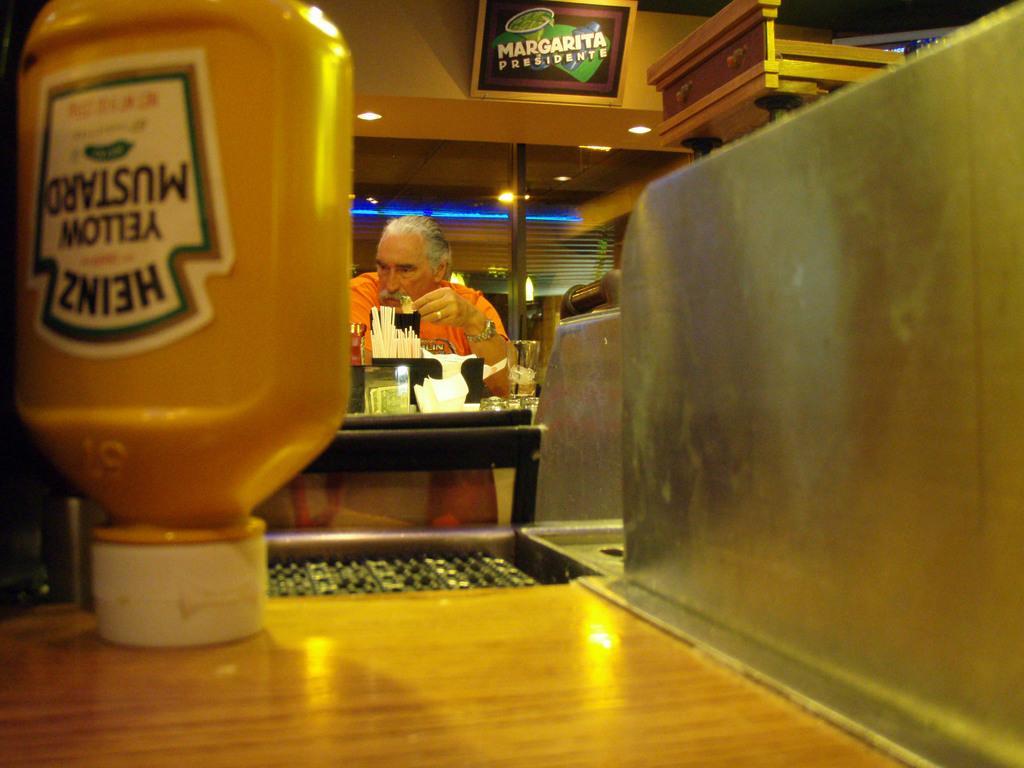How would you summarize this image in a sentence or two? In this image there is a table on that their is a bottle, in the background there is a man standing near a counter on that there are objects, at the top there is a board on that board there is some text. 